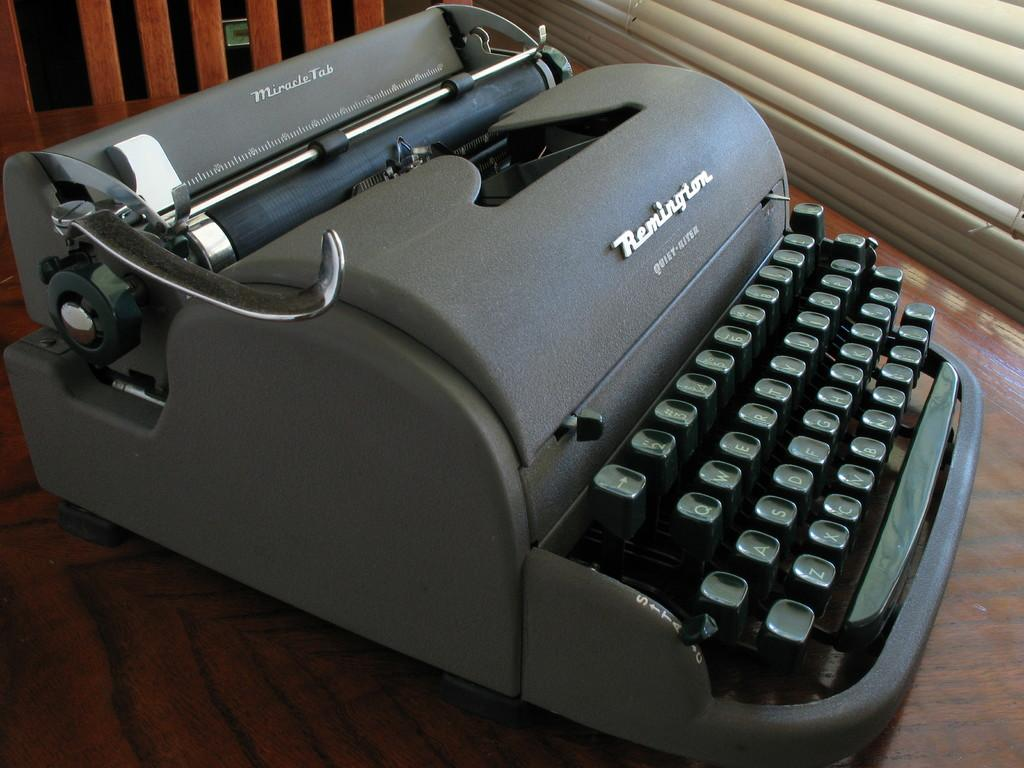<image>
Present a compact description of the photo's key features. The Quiet Riter is in very nice condition. 